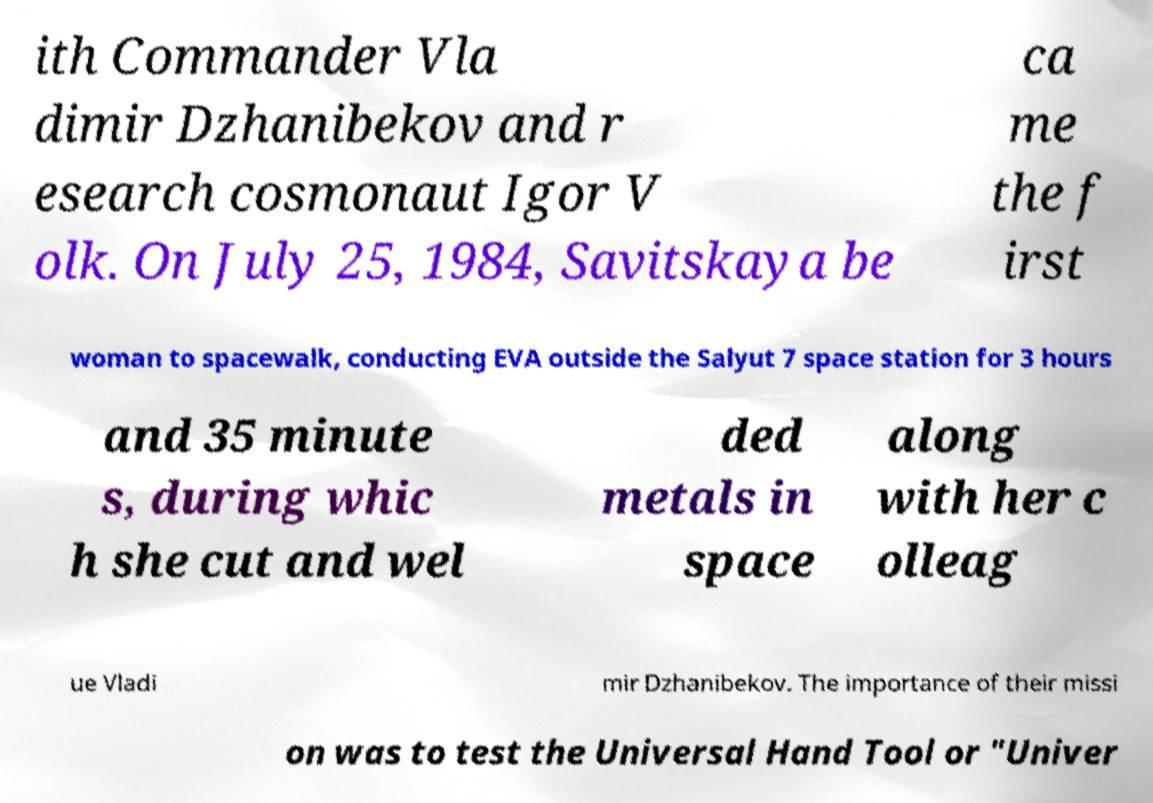Can you accurately transcribe the text from the provided image for me? ith Commander Vla dimir Dzhanibekov and r esearch cosmonaut Igor V olk. On July 25, 1984, Savitskaya be ca me the f irst woman to spacewalk, conducting EVA outside the Salyut 7 space station for 3 hours and 35 minute s, during whic h she cut and wel ded metals in space along with her c olleag ue Vladi mir Dzhanibekov. The importance of their missi on was to test the Universal Hand Tool or "Univer 